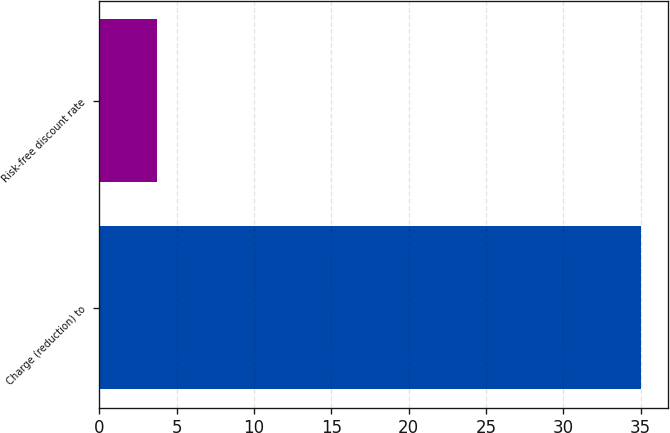<chart> <loc_0><loc_0><loc_500><loc_500><bar_chart><fcel>Charge (reduction) to<fcel>Risk-free discount rate<nl><fcel>35<fcel>3.75<nl></chart> 